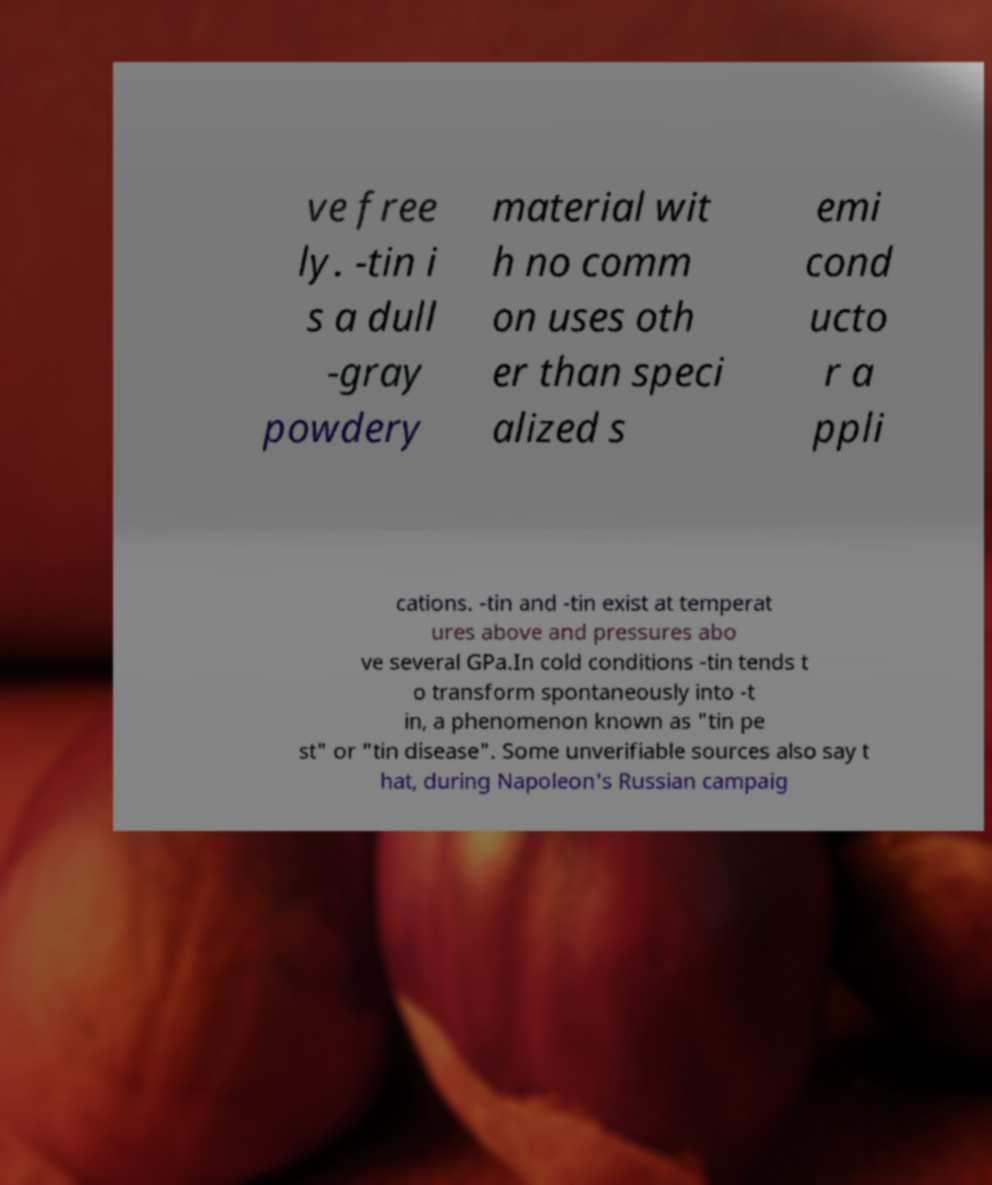Please read and relay the text visible in this image. What does it say? ve free ly. -tin i s a dull -gray powdery material wit h no comm on uses oth er than speci alized s emi cond ucto r a ppli cations. -tin and -tin exist at temperat ures above and pressures abo ve several GPa.In cold conditions -tin tends t o transform spontaneously into -t in, a phenomenon known as "tin pe st" or "tin disease". Some unverifiable sources also say t hat, during Napoleon's Russian campaig 